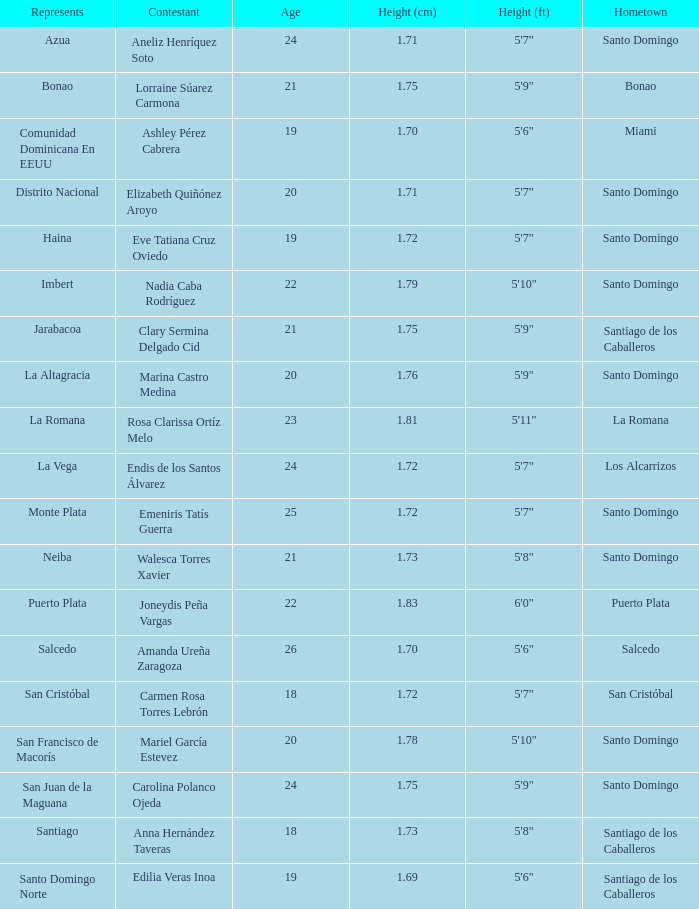Identify the maximum age. 26.0. 